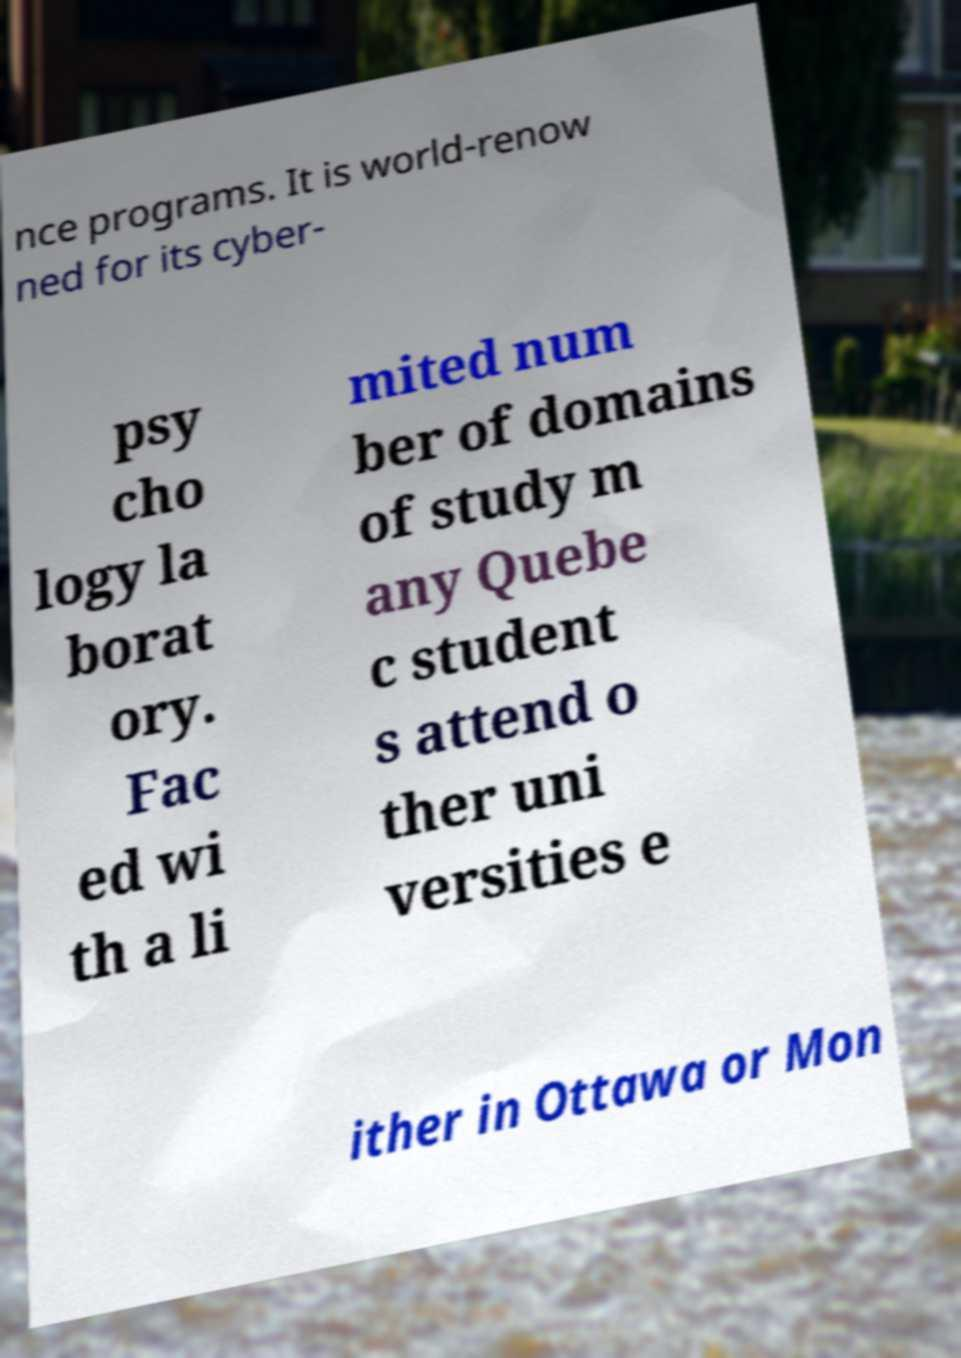Please read and relay the text visible in this image. What does it say? nce programs. It is world-renow ned for its cyber- psy cho logy la borat ory. Fac ed wi th a li mited num ber of domains of study m any Quebe c student s attend o ther uni versities e ither in Ottawa or Mon 